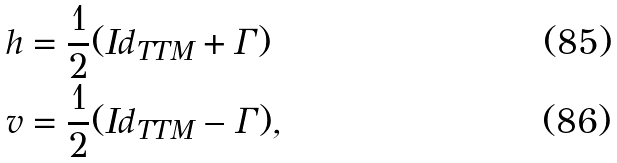<formula> <loc_0><loc_0><loc_500><loc_500>h & = \frac { 1 } { 2 } ( I d _ { T T M } + \Gamma ) \\ v & = \frac { 1 } { 2 } ( I d _ { T T M } - \Gamma ) ,</formula> 